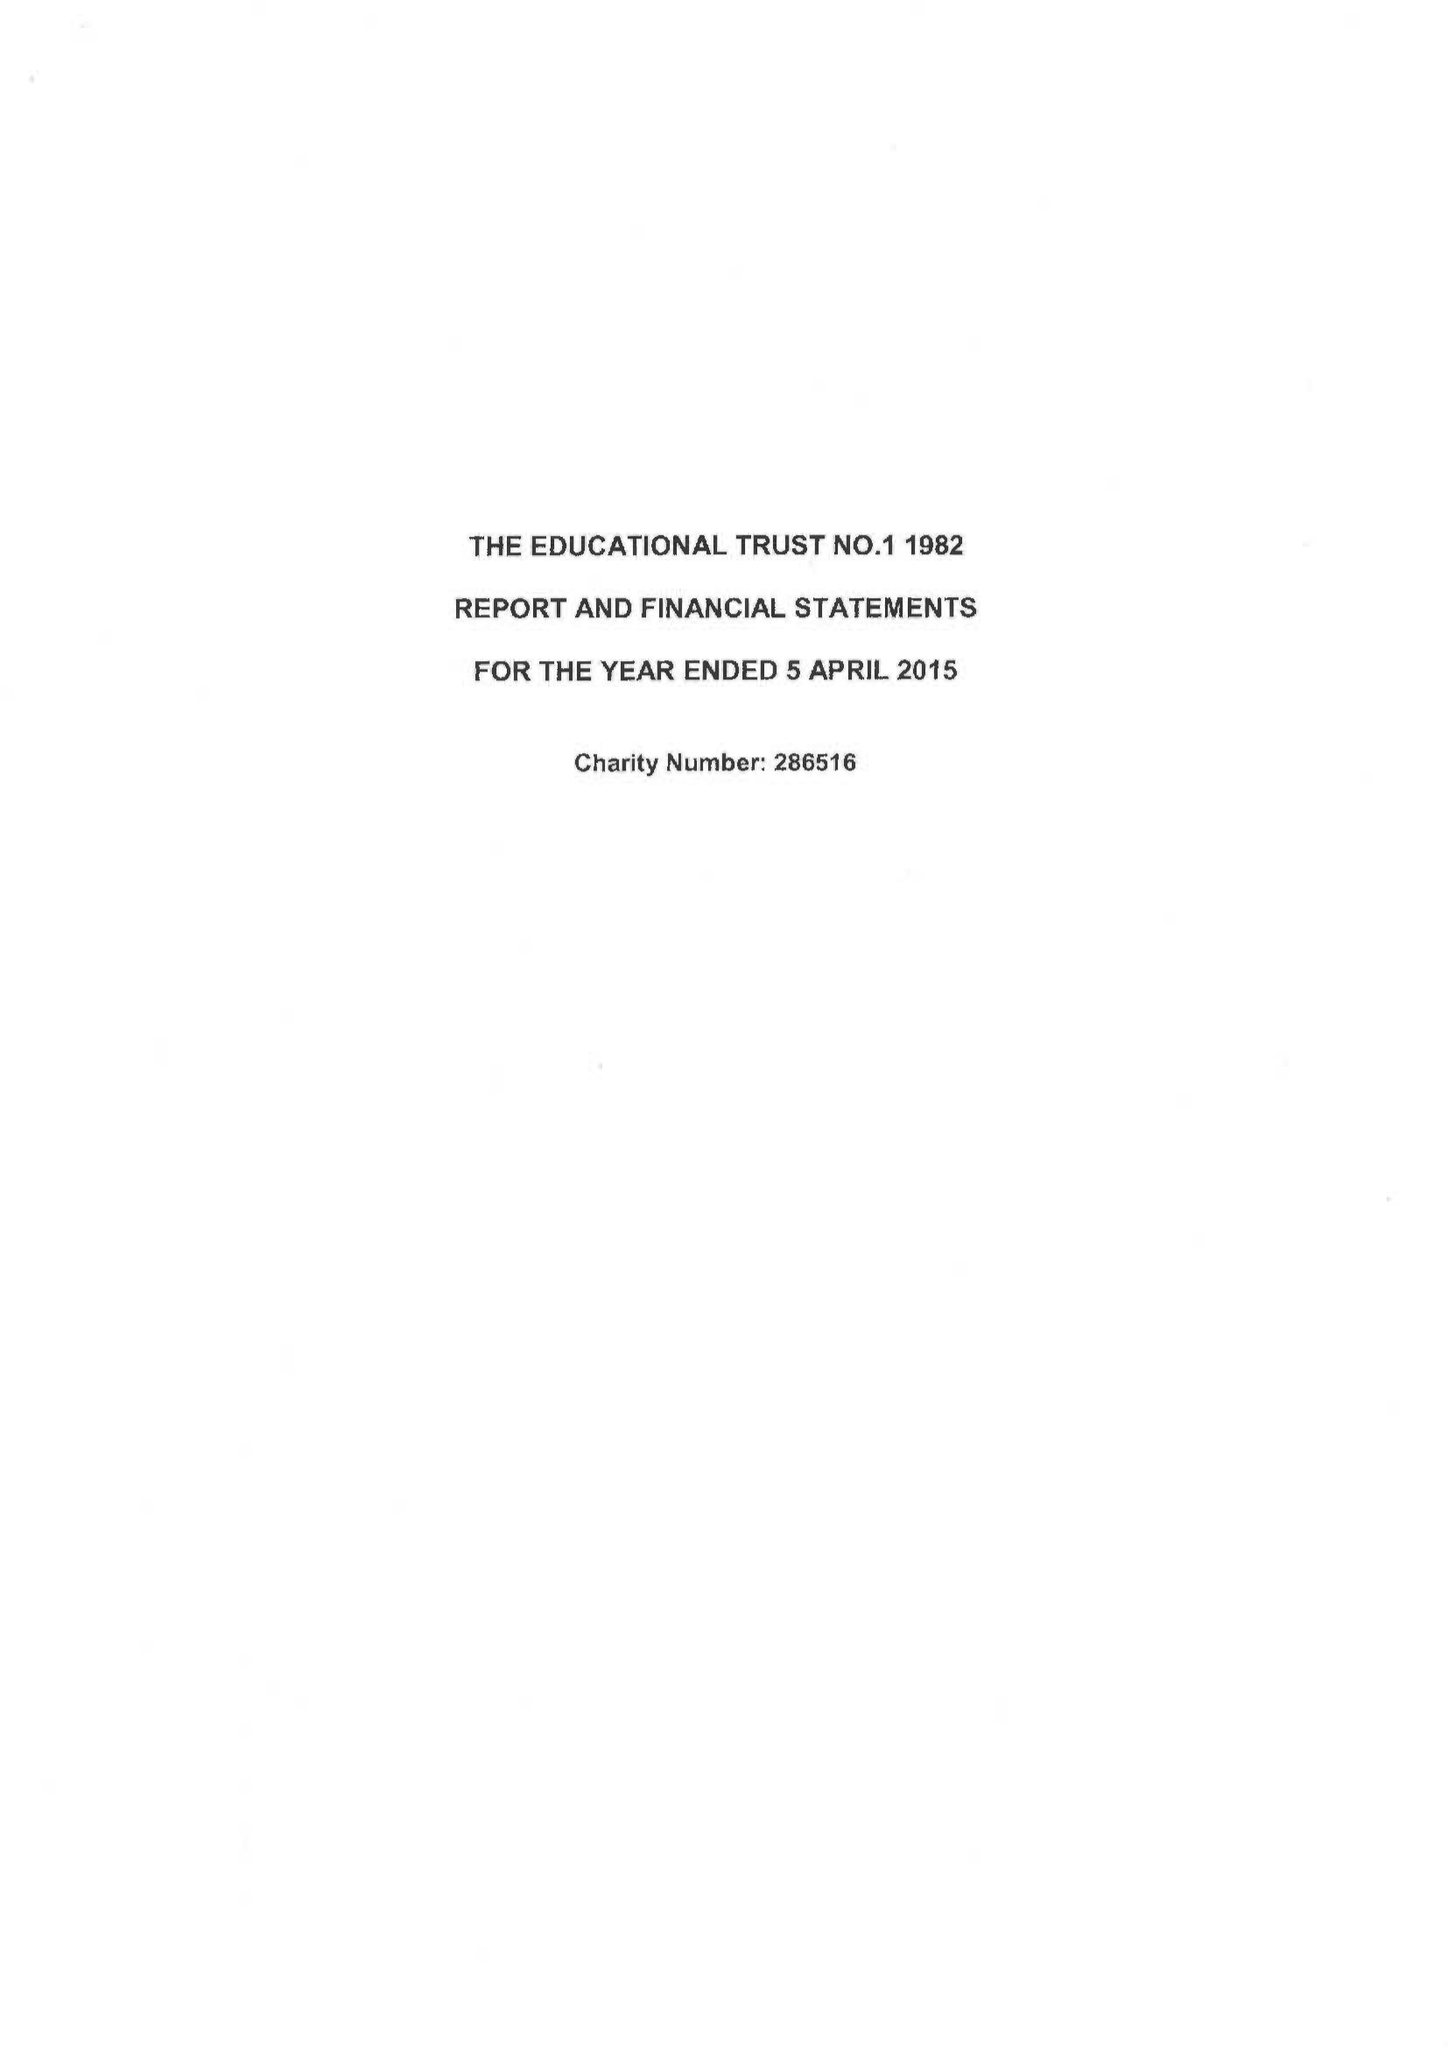What is the value for the charity_name?
Answer the question using a single word or phrase. Educational Trust No. 1 1982 